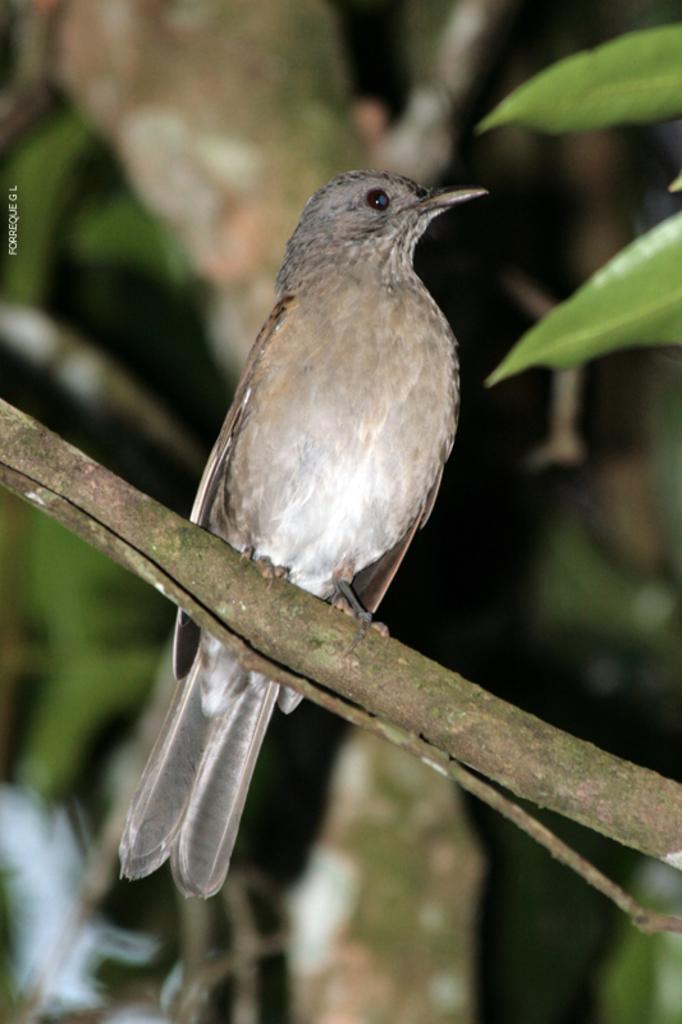Can you describe this image briefly? In this image there is a bird sitting on the stem. There is a tree in the background. 